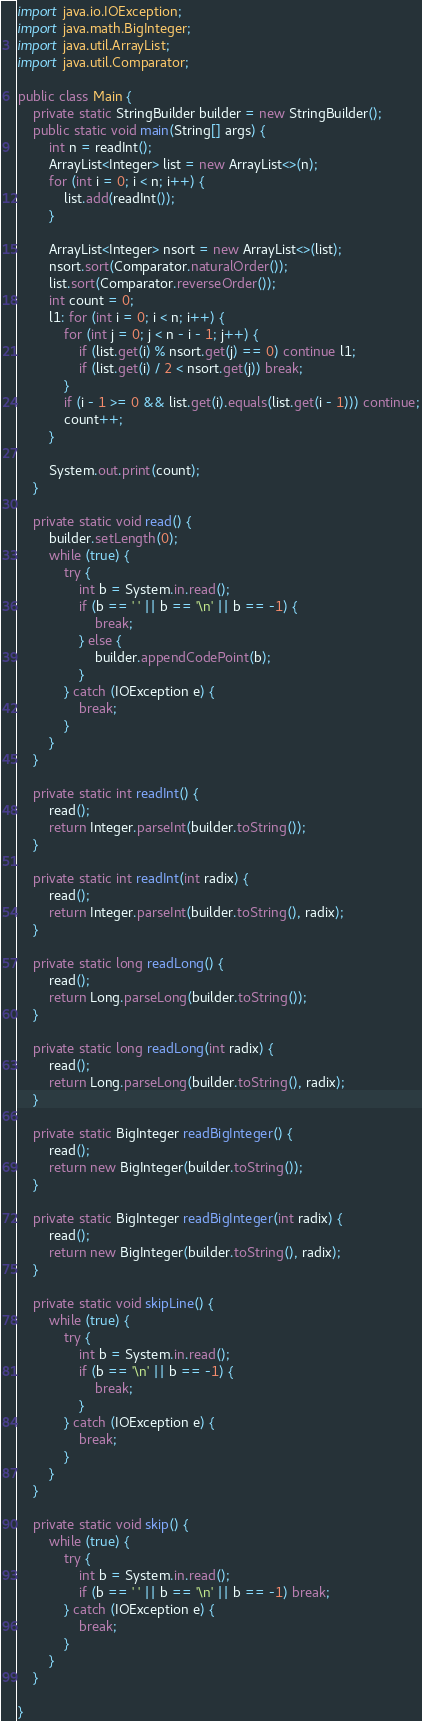Convert code to text. <code><loc_0><loc_0><loc_500><loc_500><_Java_>import java.io.IOException;
import java.math.BigInteger;
import java.util.ArrayList;
import java.util.Comparator;

public class Main {
    private static StringBuilder builder = new StringBuilder();
    public static void main(String[] args) {
        int n = readInt();
        ArrayList<Integer> list = new ArrayList<>(n);
        for (int i = 0; i < n; i++) {
            list.add(readInt());
        }

        ArrayList<Integer> nsort = new ArrayList<>(list);
        nsort.sort(Comparator.naturalOrder());
        list.sort(Comparator.reverseOrder());
        int count = 0;
        l1: for (int i = 0; i < n; i++) {
            for (int j = 0; j < n - i - 1; j++) {
                if (list.get(i) % nsort.get(j) == 0) continue l1;
                if (list.get(i) / 2 < nsort.get(j)) break;
            }
            if (i - 1 >= 0 && list.get(i).equals(list.get(i - 1))) continue;
            count++;
        }

        System.out.print(count);
    }

    private static void read() {
        builder.setLength(0);
        while (true) {
            try {
                int b = System.in.read();
                if (b == ' ' || b == '\n' || b == -1) {
                    break;
                } else {
                    builder.appendCodePoint(b);
                }
            } catch (IOException e) {
                break;
            }
        }
    }

    private static int readInt() {
        read();
        return Integer.parseInt(builder.toString());
    }

    private static int readInt(int radix) {
        read();
        return Integer.parseInt(builder.toString(), radix);
    }

    private static long readLong() {
        read();
        return Long.parseLong(builder.toString());
    }

    private static long readLong(int radix) {
        read();
        return Long.parseLong(builder.toString(), radix);
    }

    private static BigInteger readBigInteger() {
        read();
        return new BigInteger(builder.toString());
    }

    private static BigInteger readBigInteger(int radix) {
        read();
        return new BigInteger(builder.toString(), radix);
    }

    private static void skipLine() {
        while (true) {
            try {
                int b = System.in.read();
                if (b == '\n' || b == -1) {
                    break;
                }
            } catch (IOException e) {
                break;
            }
        }
    }

    private static void skip() {
        while (true) {
            try {
                int b = System.in.read();
                if (b == ' ' || b == '\n' || b == -1) break;
            } catch (IOException e) {
                break;
            }
        }
    }

}
</code> 